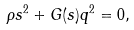Convert formula to latex. <formula><loc_0><loc_0><loc_500><loc_500>\rho s ^ { 2 } + G ( s ) q ^ { 2 } = 0 ,</formula> 